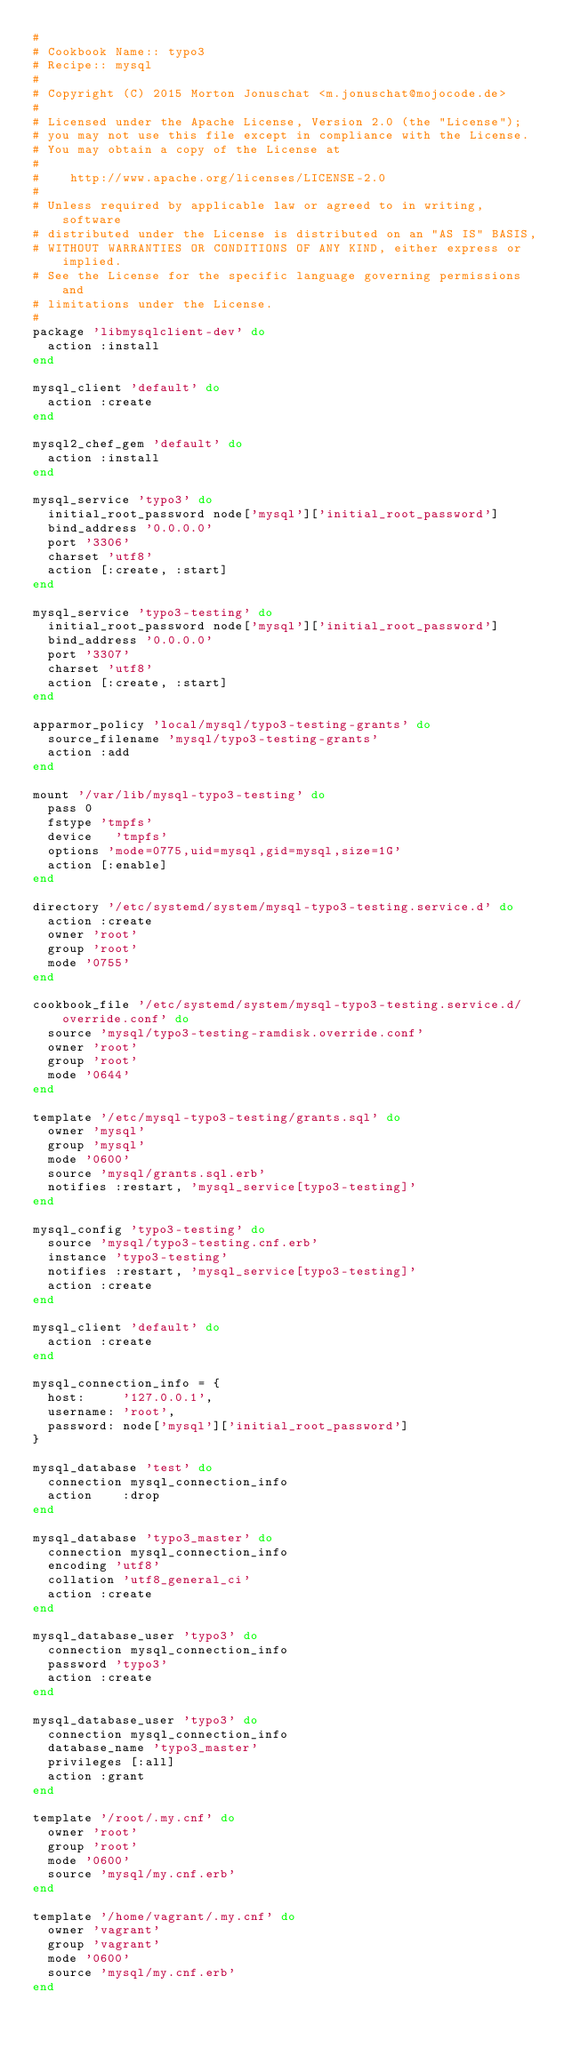Convert code to text. <code><loc_0><loc_0><loc_500><loc_500><_Ruby_>#
# Cookbook Name:: typo3
# Recipe:: mysql
#
# Copyright (C) 2015 Morton Jonuschat <m.jonuschat@mojocode.de>
#
# Licensed under the Apache License, Version 2.0 (the "License");
# you may not use this file except in compliance with the License.
# You may obtain a copy of the License at
#
#    http://www.apache.org/licenses/LICENSE-2.0
#
# Unless required by applicable law or agreed to in writing, software
# distributed under the License is distributed on an "AS IS" BASIS,
# WITHOUT WARRANTIES OR CONDITIONS OF ANY KIND, either express or implied.
# See the License for the specific language governing permissions and
# limitations under the License.
#
package 'libmysqlclient-dev' do
  action :install
end

mysql_client 'default' do
  action :create
end

mysql2_chef_gem 'default' do
  action :install
end

mysql_service 'typo3' do
  initial_root_password node['mysql']['initial_root_password']
  bind_address '0.0.0.0'
  port '3306'
  charset 'utf8'
  action [:create, :start]
end

mysql_service 'typo3-testing' do
  initial_root_password node['mysql']['initial_root_password']
  bind_address '0.0.0.0'
  port '3307'
  charset 'utf8'
  action [:create, :start]
end

apparmor_policy 'local/mysql/typo3-testing-grants' do
  source_filename 'mysql/typo3-testing-grants'
  action :add
end

mount '/var/lib/mysql-typo3-testing' do
  pass 0
  fstype 'tmpfs'
  device   'tmpfs'
  options 'mode=0775,uid=mysql,gid=mysql,size=1G'
  action [:enable]
end

directory '/etc/systemd/system/mysql-typo3-testing.service.d' do
  action :create
  owner 'root'
  group 'root'
  mode '0755'
end

cookbook_file '/etc/systemd/system/mysql-typo3-testing.service.d/override.conf' do
  source 'mysql/typo3-testing-ramdisk.override.conf'
  owner 'root'
  group 'root'
  mode '0644'
end

template '/etc/mysql-typo3-testing/grants.sql' do
  owner 'mysql'
  group 'mysql'
  mode '0600'
  source 'mysql/grants.sql.erb'
  notifies :restart, 'mysql_service[typo3-testing]'
end

mysql_config 'typo3-testing' do
  source 'mysql/typo3-testing.cnf.erb'
  instance 'typo3-testing'
  notifies :restart, 'mysql_service[typo3-testing]'
  action :create
end

mysql_client 'default' do
  action :create
end

mysql_connection_info = {
  host:     '127.0.0.1',
  username: 'root',
  password: node['mysql']['initial_root_password']
}

mysql_database 'test' do
  connection mysql_connection_info
  action    :drop
end

mysql_database 'typo3_master' do
  connection mysql_connection_info
  encoding 'utf8'
  collation 'utf8_general_ci'
  action :create
end

mysql_database_user 'typo3' do
  connection mysql_connection_info
  password 'typo3'
  action :create
end

mysql_database_user 'typo3' do
  connection mysql_connection_info
  database_name 'typo3_master'
  privileges [:all]
  action :grant
end

template '/root/.my.cnf' do
  owner 'root'
  group 'root'
  mode '0600'
  source 'mysql/my.cnf.erb'
end

template '/home/vagrant/.my.cnf' do
  owner 'vagrant'
  group 'vagrant'
  mode '0600'
  source 'mysql/my.cnf.erb'
end
</code> 